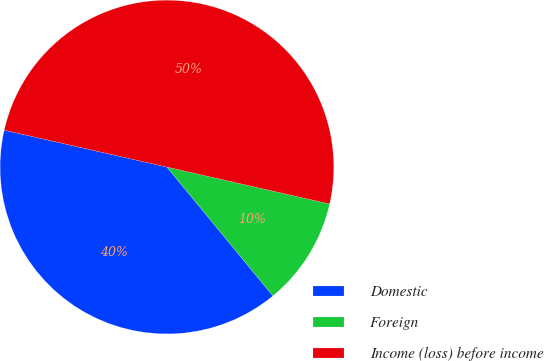Convert chart. <chart><loc_0><loc_0><loc_500><loc_500><pie_chart><fcel>Domestic<fcel>Foreign<fcel>Income (loss) before income<nl><fcel>39.51%<fcel>10.49%<fcel>50.0%<nl></chart> 